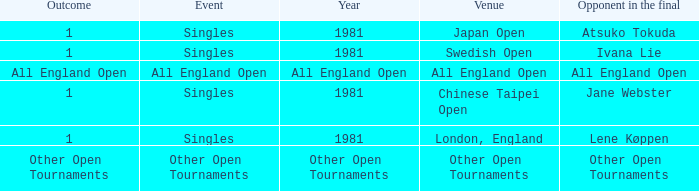What is the Outcome of the Singles Event in London, England? 1.0. 